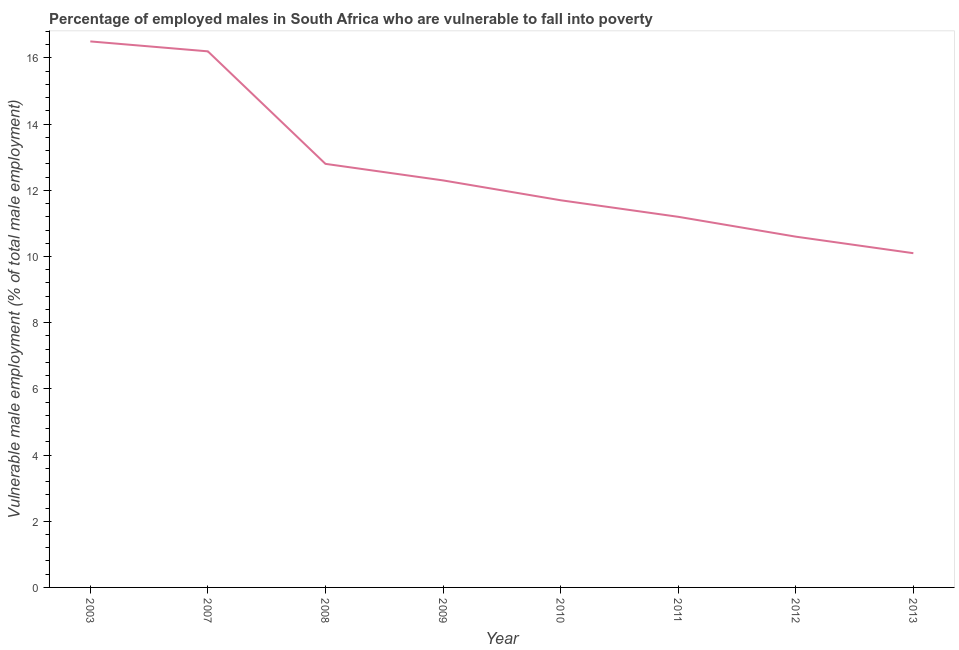What is the percentage of employed males who are vulnerable to fall into poverty in 2007?
Offer a terse response. 16.2. Across all years, what is the minimum percentage of employed males who are vulnerable to fall into poverty?
Provide a short and direct response. 10.1. In which year was the percentage of employed males who are vulnerable to fall into poverty maximum?
Provide a succinct answer. 2003. In which year was the percentage of employed males who are vulnerable to fall into poverty minimum?
Offer a terse response. 2013. What is the sum of the percentage of employed males who are vulnerable to fall into poverty?
Your answer should be compact. 101.4. What is the difference between the percentage of employed males who are vulnerable to fall into poverty in 2010 and 2013?
Ensure brevity in your answer.  1.6. What is the average percentage of employed males who are vulnerable to fall into poverty per year?
Give a very brief answer. 12.68. What is the median percentage of employed males who are vulnerable to fall into poverty?
Provide a succinct answer. 12. In how many years, is the percentage of employed males who are vulnerable to fall into poverty greater than 8.4 %?
Provide a short and direct response. 8. What is the ratio of the percentage of employed males who are vulnerable to fall into poverty in 2003 to that in 2008?
Provide a short and direct response. 1.29. Is the percentage of employed males who are vulnerable to fall into poverty in 2007 less than that in 2011?
Give a very brief answer. No. What is the difference between the highest and the second highest percentage of employed males who are vulnerable to fall into poverty?
Provide a succinct answer. 0.3. Is the sum of the percentage of employed males who are vulnerable to fall into poverty in 2010 and 2011 greater than the maximum percentage of employed males who are vulnerable to fall into poverty across all years?
Ensure brevity in your answer.  Yes. What is the difference between the highest and the lowest percentage of employed males who are vulnerable to fall into poverty?
Provide a succinct answer. 6.4. Does the percentage of employed males who are vulnerable to fall into poverty monotonically increase over the years?
Ensure brevity in your answer.  No. Are the values on the major ticks of Y-axis written in scientific E-notation?
Your answer should be very brief. No. Does the graph contain any zero values?
Your answer should be compact. No. What is the title of the graph?
Provide a succinct answer. Percentage of employed males in South Africa who are vulnerable to fall into poverty. What is the label or title of the X-axis?
Provide a succinct answer. Year. What is the label or title of the Y-axis?
Provide a short and direct response. Vulnerable male employment (% of total male employment). What is the Vulnerable male employment (% of total male employment) in 2007?
Make the answer very short. 16.2. What is the Vulnerable male employment (% of total male employment) in 2008?
Provide a succinct answer. 12.8. What is the Vulnerable male employment (% of total male employment) of 2009?
Your answer should be very brief. 12.3. What is the Vulnerable male employment (% of total male employment) of 2010?
Offer a terse response. 11.7. What is the Vulnerable male employment (% of total male employment) of 2011?
Provide a short and direct response. 11.2. What is the Vulnerable male employment (% of total male employment) of 2012?
Provide a short and direct response. 10.6. What is the Vulnerable male employment (% of total male employment) of 2013?
Your answer should be compact. 10.1. What is the difference between the Vulnerable male employment (% of total male employment) in 2003 and 2007?
Keep it short and to the point. 0.3. What is the difference between the Vulnerable male employment (% of total male employment) in 2003 and 2008?
Make the answer very short. 3.7. What is the difference between the Vulnerable male employment (% of total male employment) in 2003 and 2009?
Keep it short and to the point. 4.2. What is the difference between the Vulnerable male employment (% of total male employment) in 2003 and 2010?
Ensure brevity in your answer.  4.8. What is the difference between the Vulnerable male employment (% of total male employment) in 2003 and 2011?
Keep it short and to the point. 5.3. What is the difference between the Vulnerable male employment (% of total male employment) in 2003 and 2013?
Your response must be concise. 6.4. What is the difference between the Vulnerable male employment (% of total male employment) in 2007 and 2008?
Your response must be concise. 3.4. What is the difference between the Vulnerable male employment (% of total male employment) in 2007 and 2012?
Your answer should be very brief. 5.6. What is the difference between the Vulnerable male employment (% of total male employment) in 2008 and 2013?
Provide a succinct answer. 2.7. What is the difference between the Vulnerable male employment (% of total male employment) in 2009 and 2011?
Make the answer very short. 1.1. What is the difference between the Vulnerable male employment (% of total male employment) in 2009 and 2012?
Your response must be concise. 1.7. What is the difference between the Vulnerable male employment (% of total male employment) in 2010 and 2011?
Your response must be concise. 0.5. What is the difference between the Vulnerable male employment (% of total male employment) in 2010 and 2012?
Your response must be concise. 1.1. What is the difference between the Vulnerable male employment (% of total male employment) in 2010 and 2013?
Provide a succinct answer. 1.6. What is the difference between the Vulnerable male employment (% of total male employment) in 2012 and 2013?
Your answer should be compact. 0.5. What is the ratio of the Vulnerable male employment (% of total male employment) in 2003 to that in 2008?
Ensure brevity in your answer.  1.29. What is the ratio of the Vulnerable male employment (% of total male employment) in 2003 to that in 2009?
Keep it short and to the point. 1.34. What is the ratio of the Vulnerable male employment (% of total male employment) in 2003 to that in 2010?
Offer a very short reply. 1.41. What is the ratio of the Vulnerable male employment (% of total male employment) in 2003 to that in 2011?
Your answer should be compact. 1.47. What is the ratio of the Vulnerable male employment (% of total male employment) in 2003 to that in 2012?
Your answer should be compact. 1.56. What is the ratio of the Vulnerable male employment (% of total male employment) in 2003 to that in 2013?
Provide a succinct answer. 1.63. What is the ratio of the Vulnerable male employment (% of total male employment) in 2007 to that in 2008?
Provide a succinct answer. 1.27. What is the ratio of the Vulnerable male employment (% of total male employment) in 2007 to that in 2009?
Ensure brevity in your answer.  1.32. What is the ratio of the Vulnerable male employment (% of total male employment) in 2007 to that in 2010?
Offer a very short reply. 1.39. What is the ratio of the Vulnerable male employment (% of total male employment) in 2007 to that in 2011?
Keep it short and to the point. 1.45. What is the ratio of the Vulnerable male employment (% of total male employment) in 2007 to that in 2012?
Give a very brief answer. 1.53. What is the ratio of the Vulnerable male employment (% of total male employment) in 2007 to that in 2013?
Your answer should be compact. 1.6. What is the ratio of the Vulnerable male employment (% of total male employment) in 2008 to that in 2009?
Your answer should be very brief. 1.04. What is the ratio of the Vulnerable male employment (% of total male employment) in 2008 to that in 2010?
Your answer should be very brief. 1.09. What is the ratio of the Vulnerable male employment (% of total male employment) in 2008 to that in 2011?
Provide a short and direct response. 1.14. What is the ratio of the Vulnerable male employment (% of total male employment) in 2008 to that in 2012?
Give a very brief answer. 1.21. What is the ratio of the Vulnerable male employment (% of total male employment) in 2008 to that in 2013?
Make the answer very short. 1.27. What is the ratio of the Vulnerable male employment (% of total male employment) in 2009 to that in 2010?
Your answer should be compact. 1.05. What is the ratio of the Vulnerable male employment (% of total male employment) in 2009 to that in 2011?
Offer a very short reply. 1.1. What is the ratio of the Vulnerable male employment (% of total male employment) in 2009 to that in 2012?
Keep it short and to the point. 1.16. What is the ratio of the Vulnerable male employment (% of total male employment) in 2009 to that in 2013?
Offer a terse response. 1.22. What is the ratio of the Vulnerable male employment (% of total male employment) in 2010 to that in 2011?
Your answer should be compact. 1.04. What is the ratio of the Vulnerable male employment (% of total male employment) in 2010 to that in 2012?
Your answer should be compact. 1.1. What is the ratio of the Vulnerable male employment (% of total male employment) in 2010 to that in 2013?
Make the answer very short. 1.16. What is the ratio of the Vulnerable male employment (% of total male employment) in 2011 to that in 2012?
Ensure brevity in your answer.  1.06. What is the ratio of the Vulnerable male employment (% of total male employment) in 2011 to that in 2013?
Make the answer very short. 1.11. What is the ratio of the Vulnerable male employment (% of total male employment) in 2012 to that in 2013?
Keep it short and to the point. 1.05. 